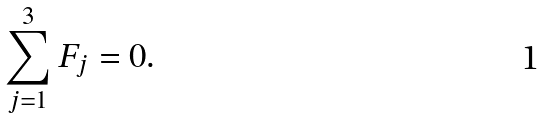<formula> <loc_0><loc_0><loc_500><loc_500>\sum _ { j = 1 } ^ { 3 } { F } _ { j } = 0 .</formula> 